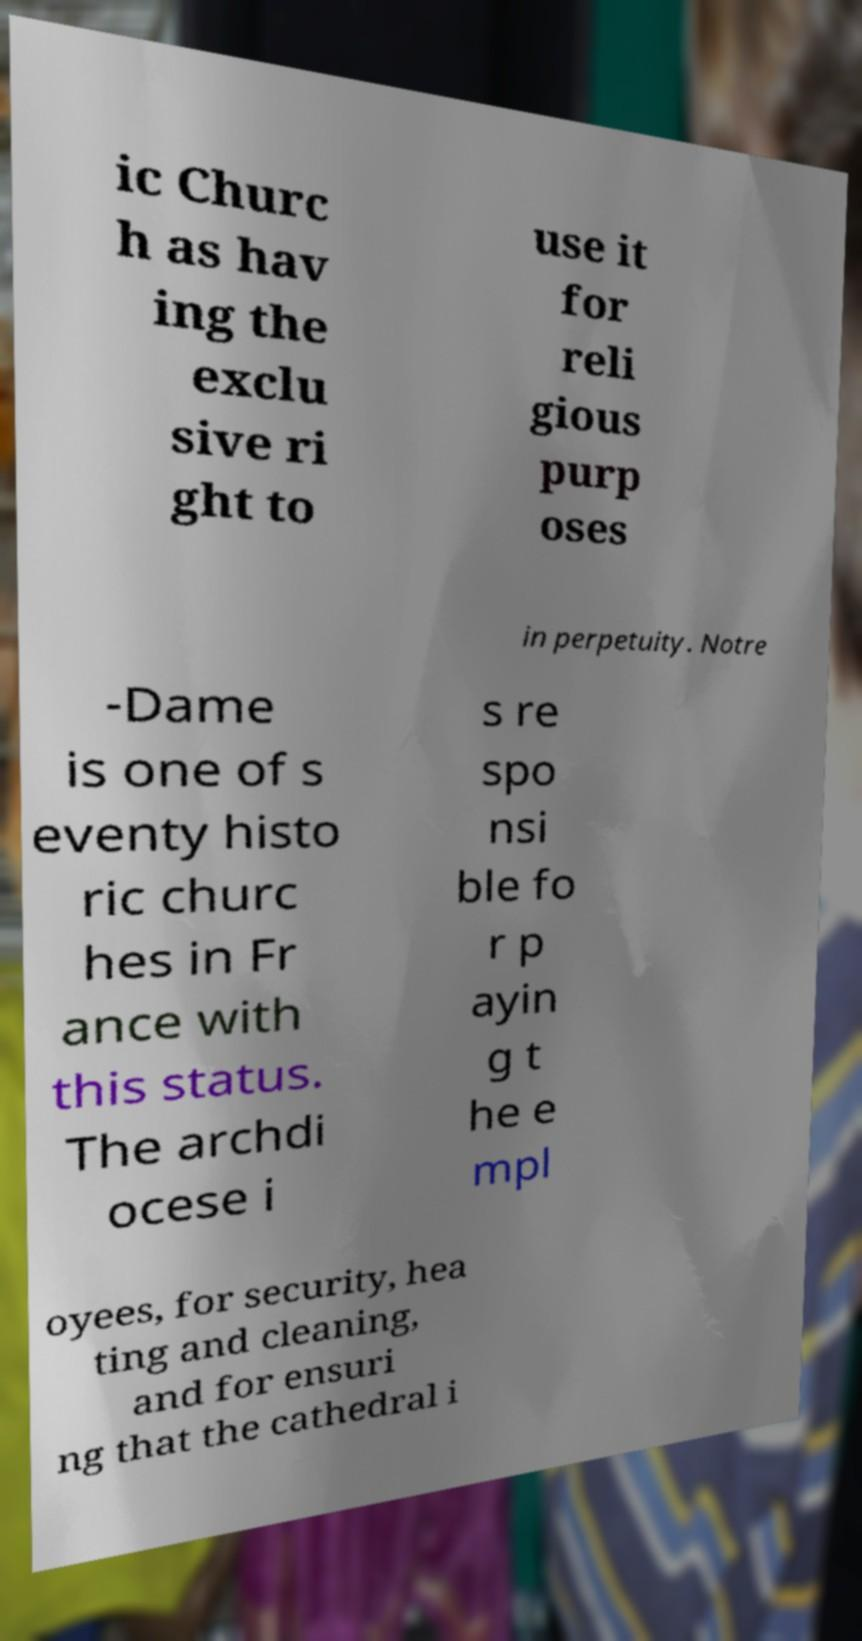Please identify and transcribe the text found in this image. ic Churc h as hav ing the exclu sive ri ght to use it for reli gious purp oses in perpetuity. Notre -Dame is one of s eventy histo ric churc hes in Fr ance with this status. The archdi ocese i s re spo nsi ble fo r p ayin g t he e mpl oyees, for security, hea ting and cleaning, and for ensuri ng that the cathedral i 